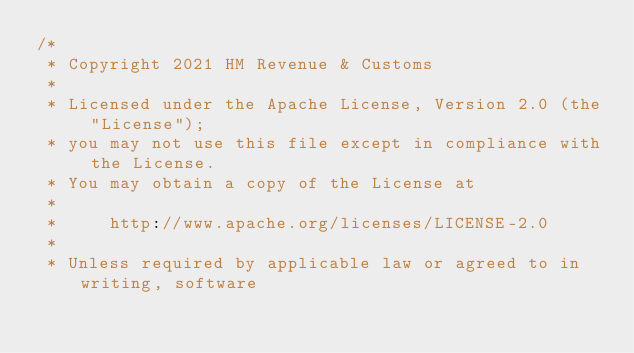Convert code to text. <code><loc_0><loc_0><loc_500><loc_500><_Scala_>/*
 * Copyright 2021 HM Revenue & Customs
 *
 * Licensed under the Apache License, Version 2.0 (the "License");
 * you may not use this file except in compliance with the License.
 * You may obtain a copy of the License at
 *
 *     http://www.apache.org/licenses/LICENSE-2.0
 *
 * Unless required by applicable law or agreed to in writing, software</code> 